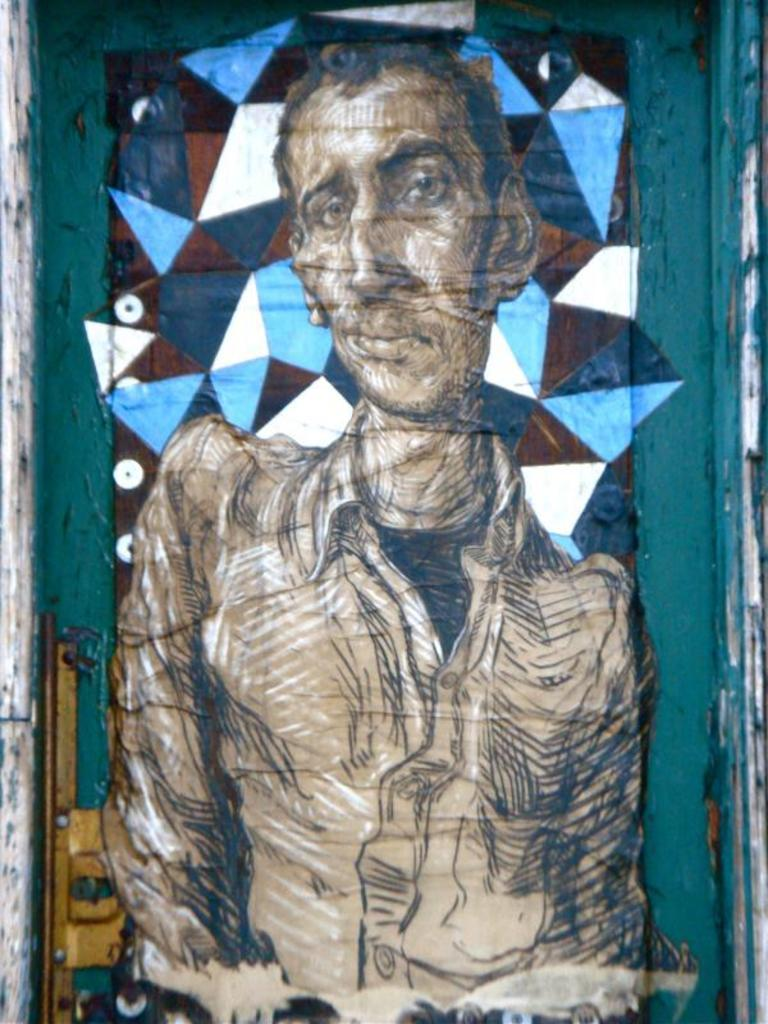What is depicted in the painting in the image? There is a painting of a person in the image. What colors are used in the painting? The painting has cream, black, and white colors. What colors are present in the background of the painting? The background of the painting has green, blue, and white colors. What type of card can be seen being used with the plough in the image? There is no card or plough present in the image; it features a painting of a person. What can be done with the can in the image? There is no can present in the image. 